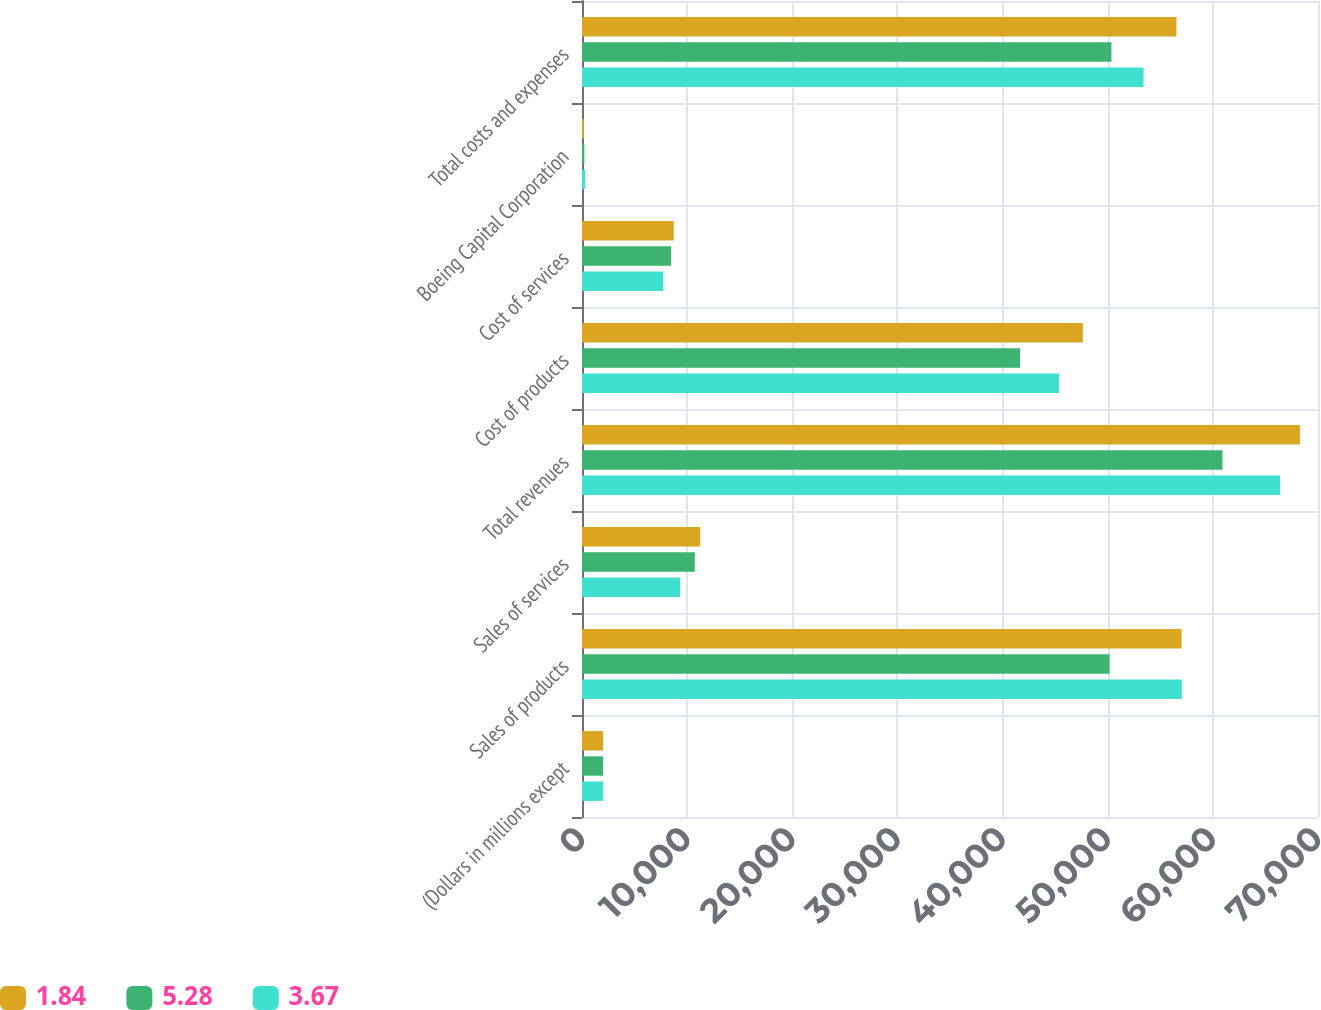Convert chart. <chart><loc_0><loc_0><loc_500><loc_500><stacked_bar_chart><ecel><fcel>(Dollars in millions except<fcel>Sales of products<fcel>Sales of services<fcel>Total revenues<fcel>Cost of products<fcel>Cost of services<fcel>Boeing Capital Corporation<fcel>Total costs and expenses<nl><fcel>1.84<fcel>2009<fcel>57032<fcel>11249<fcel>68281<fcel>47639<fcel>8726<fcel>175<fcel>56540<nl><fcel>5.28<fcel>2008<fcel>50180<fcel>10729<fcel>60909<fcel>41662<fcel>8467<fcel>223<fcel>50352<nl><fcel>3.67<fcel>2007<fcel>57049<fcel>9338<fcel>66387<fcel>45375<fcel>7732<fcel>295<fcel>53402<nl></chart> 